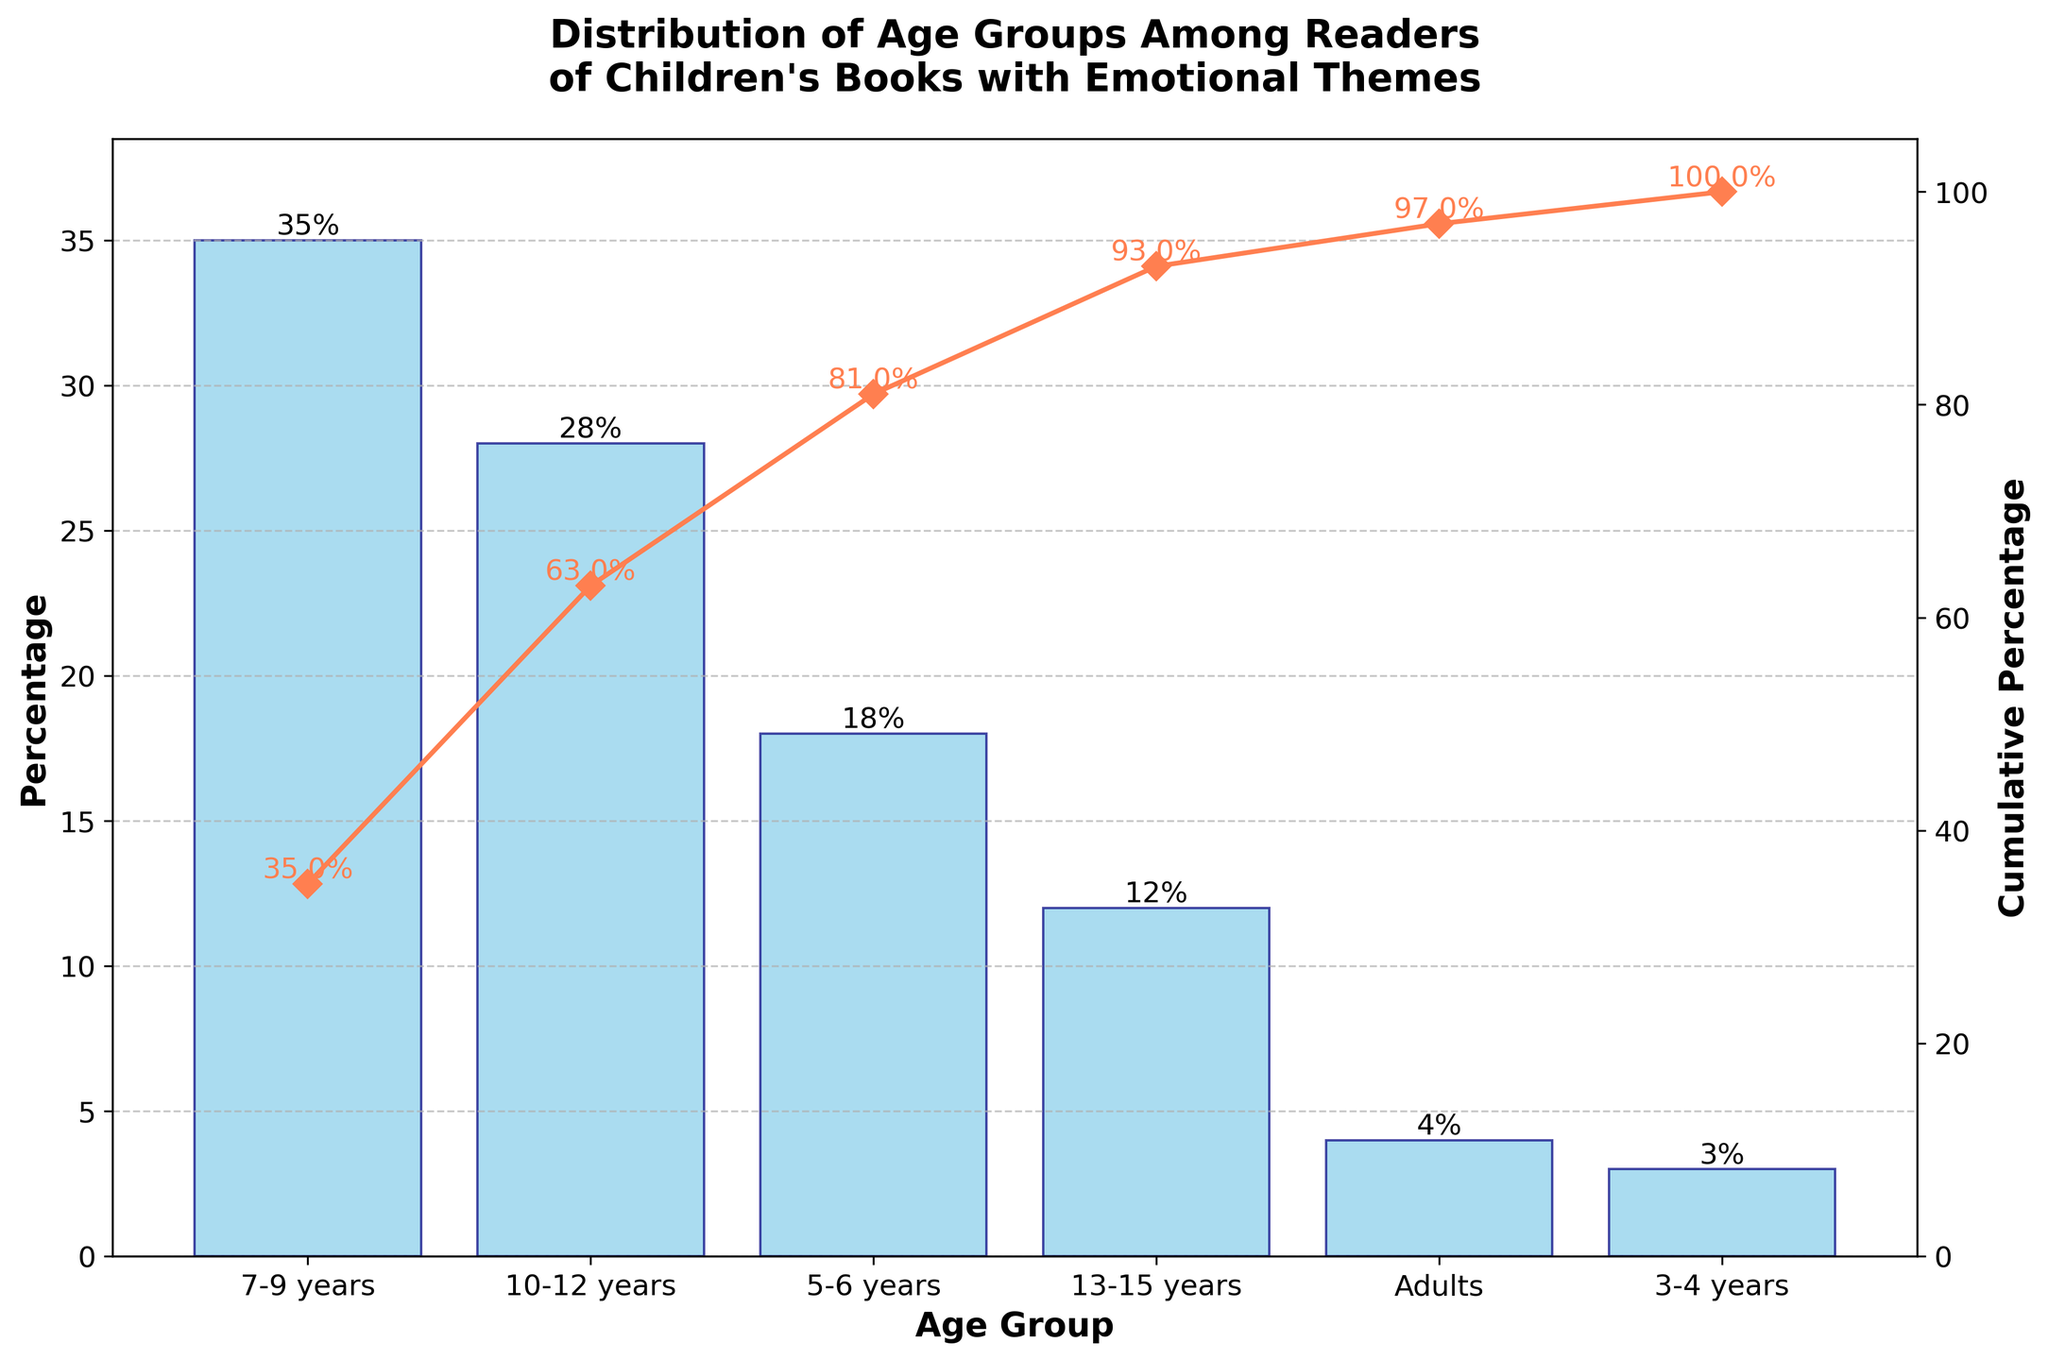What is the title of the graph? The title of the graph appears prominently at the top and summarizes the visualization as "Distribution of Age Groups Among Readers of Children's Books with Emotional Themes".
Answer: Distribution of Age Groups Among Readers of Children's Books with Emotional Themes Which age group has the highest percentage of readers? The tallest bar in the chart represents the age group with the highest percentage. The 7-9 years age group has the highest percentage at 35%.
Answer: 7-9 years What is the cumulative percentage for the 10-12 years age group? The line plot represents cumulative percentages. At the 10-12 years age group, the cumulative percentage reaches 63%.
Answer: 63% How much higher is the percentage of readers aged 7-9 years compared to those aged 3-4 years? The difference in percentages can be found by subtracting the 3% of the 3-4 years age group from the 35% of the 7-9 years age group. The difference is 35% - 3% = 32%.
Answer: 32% What is the combined percentage of readers aged 5-6 years and 10-12 years? Sum the percentages of the 5-6 years (18%) and 10-12 years (28%) age groups to get the combined percentage: 18% + 28% = 46%.
Answer: 46% Which two age groups have a cumulative percentage close to 75%? Look at the cumulative line and find where it is closest to 75%. From the graph, the 7-9 years, 10-12 years, and 5-6 years groups collectively sum up to approximately 81%, while excluding 5-6 years results in 63%. Therefore, the groups close to 75% are 7-9 years, 10-12 years, and 5-6 years individually don’t fit perfectly but jointly it fits closely.
Answer: 7-9 years, 10-12 years, 5-6 years Among adults and the 13-15 years age group, which has a higher percentage of readers? Compare the height of the bars for the adults (4%) and the 13-15 years (12%) age groups, revealing that the 13-15 years group has a higher percentage.
Answer: 13-15 years What percentage of readers are either in the 3-4 years or adults age groups? Add the percentages of the 3-4 years (3%) and adults (4%) age groups: 3% + 4% = 7%.
Answer: 7% How many age groups are represented in the chart? Count the number of bars representing each age group. There are six age groups in the chart: 7-9 years, 10-12 years, 5-6 years, 13-15 years, adults, and 3-4 years.
Answer: 6 What can you infer about the target audience for children's books with emotional themes based on this chart? The majority of readers are aged between 7 and 12 years, as seen by the substantial cumulative percentage (63%) of this age group, indicating that children's books with emotional themes primarily attract younger children.
Answer: Younger children (primarily aged 7-12 years) 